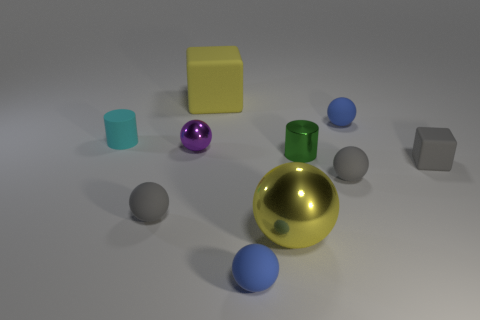What number of other green cylinders are the same size as the green cylinder?
Your answer should be very brief. 0. The rubber object that is the same color as the large shiny thing is what size?
Make the answer very short. Large. Does the large matte cube have the same color as the big sphere?
Your response must be concise. Yes. The tiny purple metallic object has what shape?
Your answer should be very brief. Sphere. Are there any tiny objects that have the same color as the tiny metal cylinder?
Give a very brief answer. No. Are there more matte spheres on the left side of the big yellow matte block than large green cylinders?
Provide a short and direct response. Yes. Do the tiny purple object and the yellow object that is in front of the big matte cube have the same shape?
Offer a terse response. Yes. Are any tiny green metal things visible?
Provide a short and direct response. Yes. What number of big objects are blue rubber objects or purple objects?
Provide a short and direct response. 0. Is the number of metal balls behind the gray block greater than the number of large yellow spheres that are to the right of the yellow metal sphere?
Your answer should be very brief. Yes. 